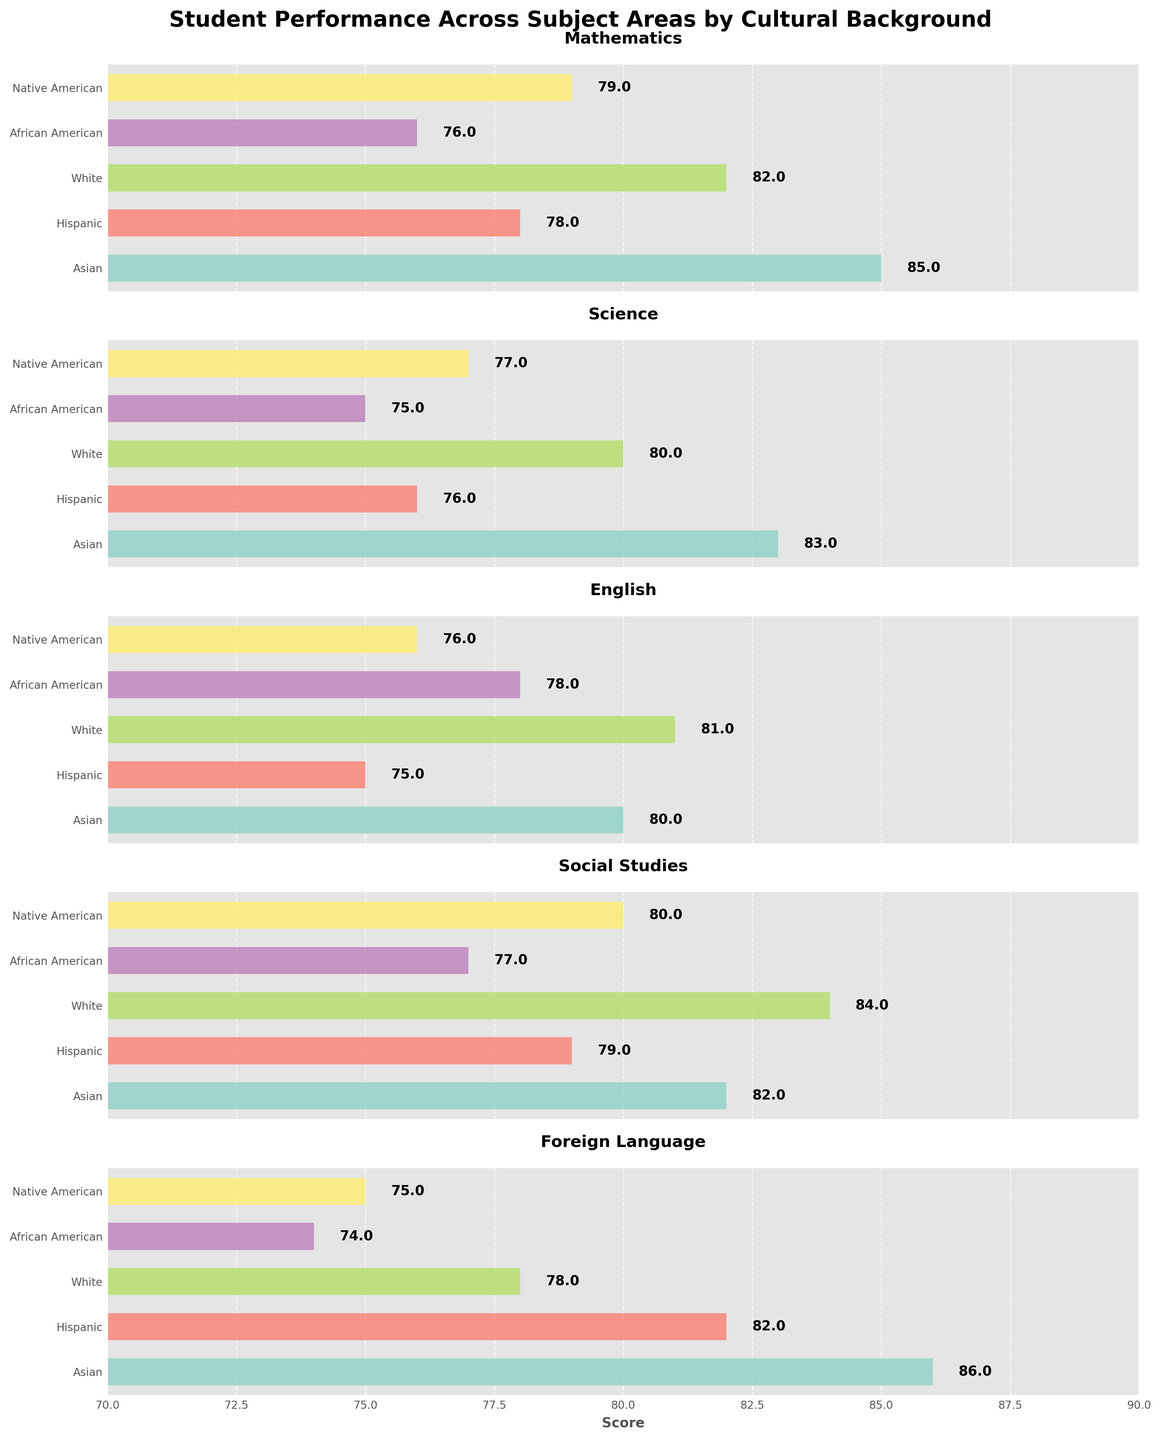What is the highest score in Mathematics? The highest score in the Mathematics plot is represented by the tallest bar, which corresponds to the Asian group.
Answer: 85 Which subject shows the smallest difference in scores among the cultural groups? By observing all plots, English has the smallest range, with scores ranging from 75 to 81.
Answer: English What is the average score of Native American students across all subjects? First, add up the scores for Native American students: 79 (Math) + 77 (Science) + 76 (English) + 80 (Social Studies) + 75 (Foreign Language) = 387. Divide this sum by the number of subjects (5), i.e., 387/5 = 77.4.
Answer: 77.4 How do Hispanic students perform in Social Studies compared to Foreign Language? In the Foreign Language plot, the value for Hispanic students is 82, and in Social Studies, it is 79. Thus, Hispanic students perform better in Foreign Language.
Answer: Better in Foreign Language Which subject area sees African American students scoring above 75 in all subjects? Checking all subplots, African American students have scores above 75 in Mathematics (76), Science (75), English (78), and Social Studies (77), but not in Foreign Language (74). Therefore, only Mathematics, Science, English, and Social Studies meet this criterion.
Answer: Mathematics, Science, English, Social Studies What is the difference in Science scores between the highest and the lowest scoring cultural backgrounds? The highest score in Science is for Asian students (83), and the lowest score is for African American students (75). The difference is then 83 - 75 = 8.
Answer: 8 Which cultural group scores consistently above 80 in all subjects except one? Observing all subplots, the Asian group consistently scores above 80 in all subjects except English (80 exactly).
Answer: Asian How much higher is the score of Asian students compared to Native American students in Foreign Language? In Foreign Language, Asian students score 86 and Native American students score 75. The difference is 86 - 75 = 11 points.
Answer: 11 Which subject shows the widest range of scores among the cultural groups? The Foreign Language subject shows the widest range since the scores vary from 74 (African American) to 86 (Asian), a range of 12 points.
Answer: Foreign Language How well do White students perform in English compared to Mathematics? White students score 81 in English and 82 in Mathematics. Therefore, their performance in both subjects is almost similar, with only a 1-point difference.
Answer: Similar performance, Mathematics slightly higher 